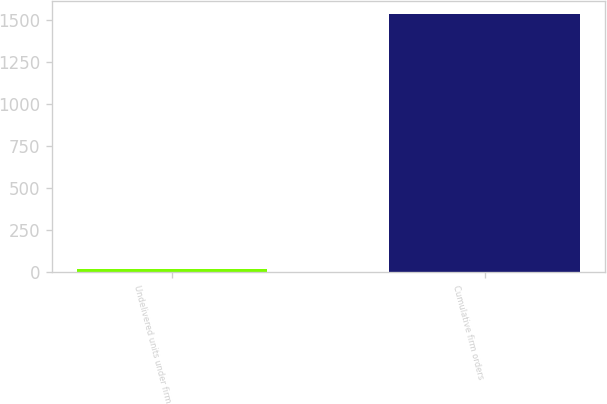Convert chart to OTSL. <chart><loc_0><loc_0><loc_500><loc_500><bar_chart><fcel>Undelivered units under firm<fcel>Cumulative firm orders<nl><fcel>20<fcel>1539<nl></chart> 